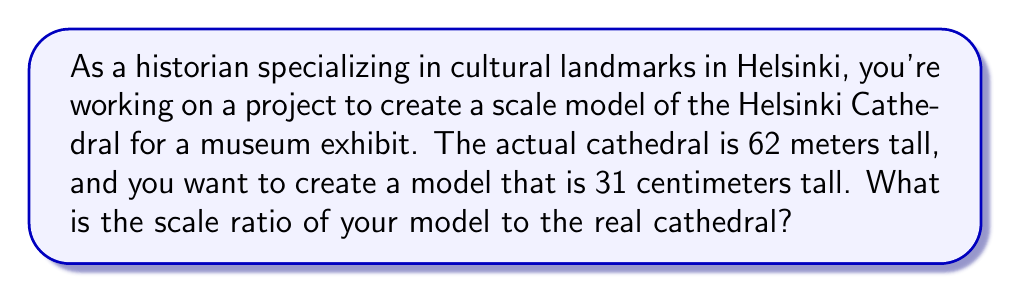Can you solve this math problem? To find the scale ratio, we need to compare the dimensions of the model to the real-world landmark. In this case, we'll use the height of the Helsinki Cathedral.

1. Convert both measurements to the same unit:
   Real cathedral height: 62 meters = 6200 cm
   Model height: 31 cm

2. Set up the ratio of model size to real size:
   $\frac{\text{Model size}}{\text{Real size}} = \frac{31 \text{ cm}}{6200 \text{ cm}}$

3. Simplify the fraction:
   $$\frac{31}{6200} = \frac{1}{200}$$

4. Express the ratio in the form 1:x
   1:200

This means that 1 unit in the model represents 200 units in the real cathedral.

To verify:
$31 \text{ cm} \times 200 = 6200 \text{ cm} = 62 \text{ m}$ (the actual height of the cathedral)
Answer: The scale ratio of the model to the real Helsinki Cathedral is 1:200. 